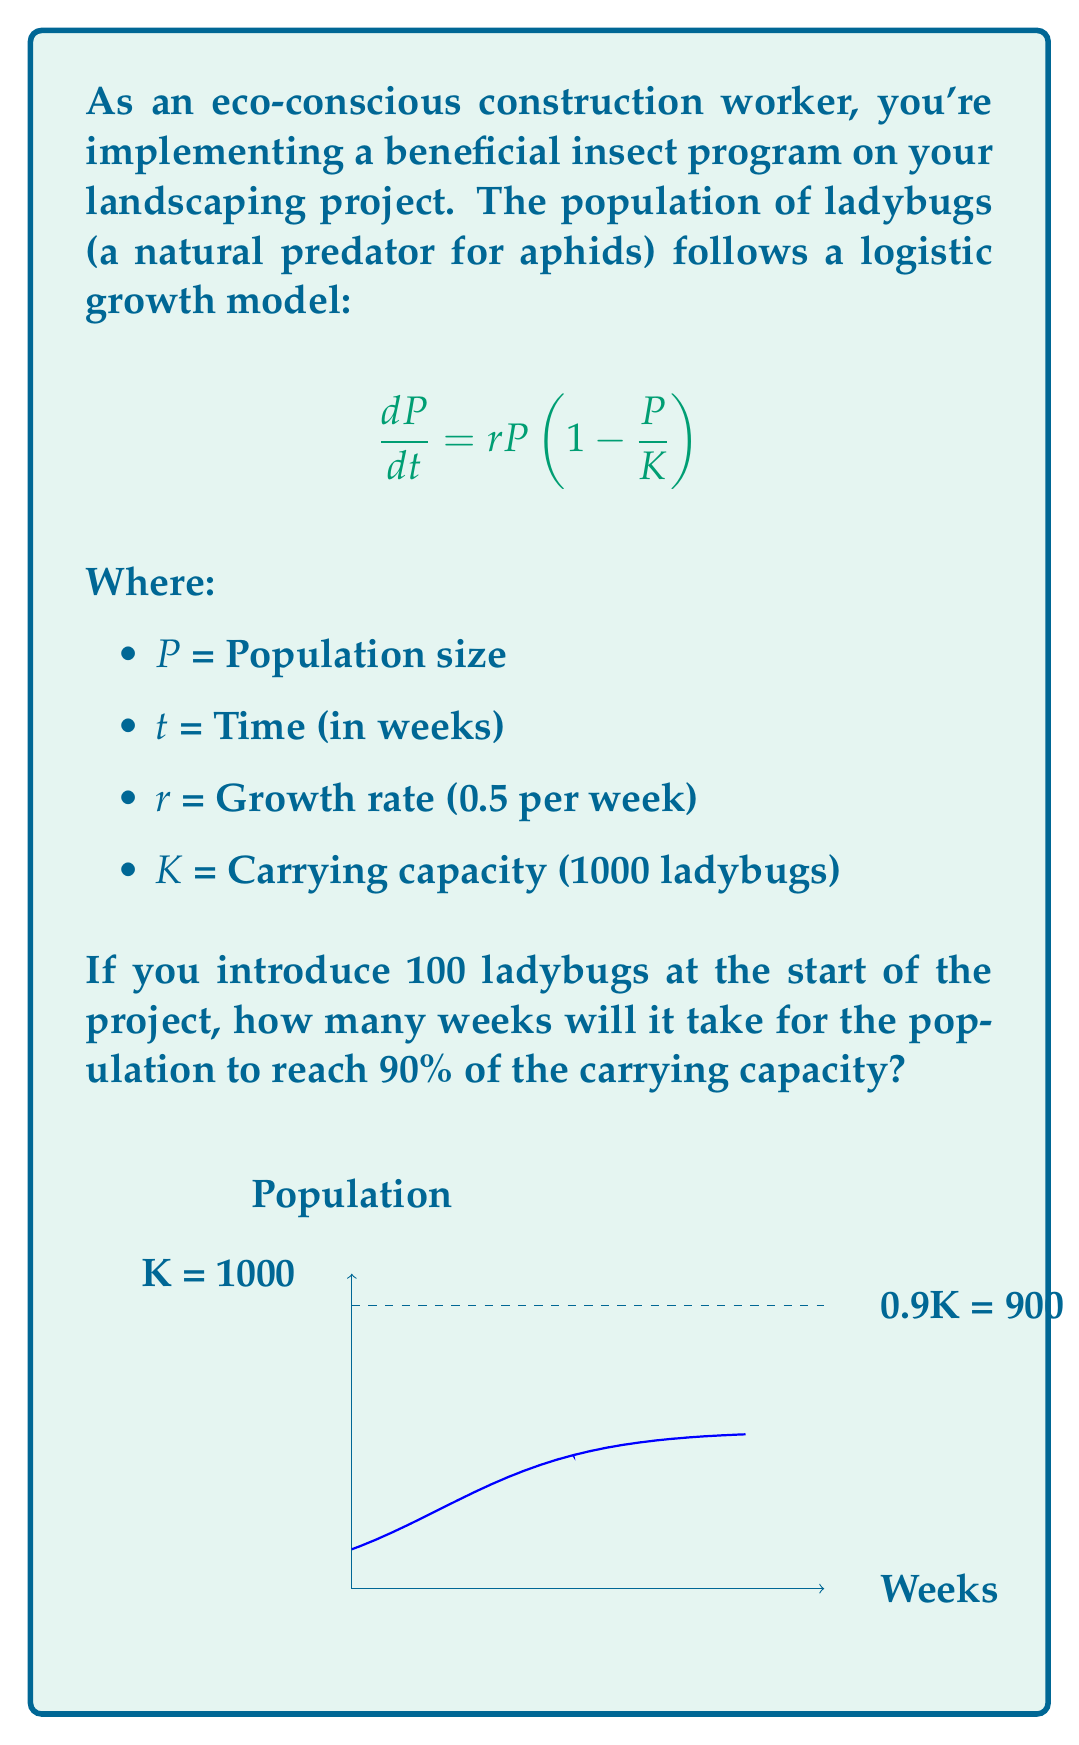Can you answer this question? To solve this problem, we'll use the analytical solution of the logistic growth model and solve for time t:

1) The solution to the logistic growth equation is:

   $$P(t) = \frac{K}{1 + \left(\frac{K}{P_0} - 1\right)e^{-rt}}$$

   Where $P_0$ is the initial population.

2) We want to find t when P(t) = 0.9K = 900. Substituting our known values:

   $$900 = \frac{1000}{1 + \left(\frac{1000}{100} - 1\right)e^{-0.5t}}$$

3) Simplify:

   $$900 = \frac{1000}{1 + 9e^{-0.5t}}$$

4) Multiply both sides by $(1 + 9e^{-0.5t})$:

   $$900(1 + 9e^{-0.5t}) = 1000$$

5) Expand:

   $$900 + 8100e^{-0.5t} = 1000$$

6) Subtract 900 from both sides:

   $$8100e^{-0.5t} = 100$$

7) Divide both sides by 8100:

   $$e^{-0.5t} = \frac{1}{81}$$

8) Take the natural log of both sides:

   $$-0.5t = \ln\left(\frac{1}{81}\right) = -\ln(81)$$

9) Divide both sides by -0.5:

   $$t = \frac{\ln(81)}{0.5} \approx 8.78$$

Therefore, it will take approximately 8.78 weeks for the ladybug population to reach 90% of the carrying capacity.
Answer: 8.78 weeks 